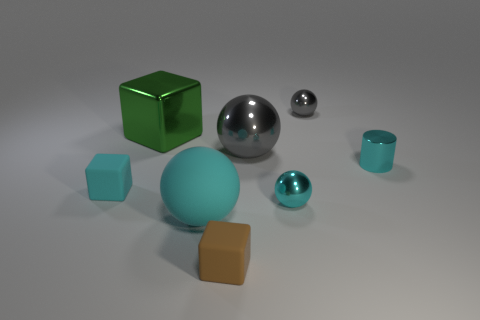Add 1 small rubber blocks. How many objects exist? 9 Subtract all cyan blocks. How many blocks are left? 2 Subtract all brown blocks. How many blocks are left? 2 Subtract all cylinders. How many objects are left? 7 Subtract all blue cylinders. How many green balls are left? 0 Subtract all purple cubes. Subtract all big metallic cubes. How many objects are left? 7 Add 4 large gray metallic spheres. How many large gray metallic spheres are left? 5 Add 2 cyan cubes. How many cyan cubes exist? 3 Subtract 0 purple cylinders. How many objects are left? 8 Subtract 1 cylinders. How many cylinders are left? 0 